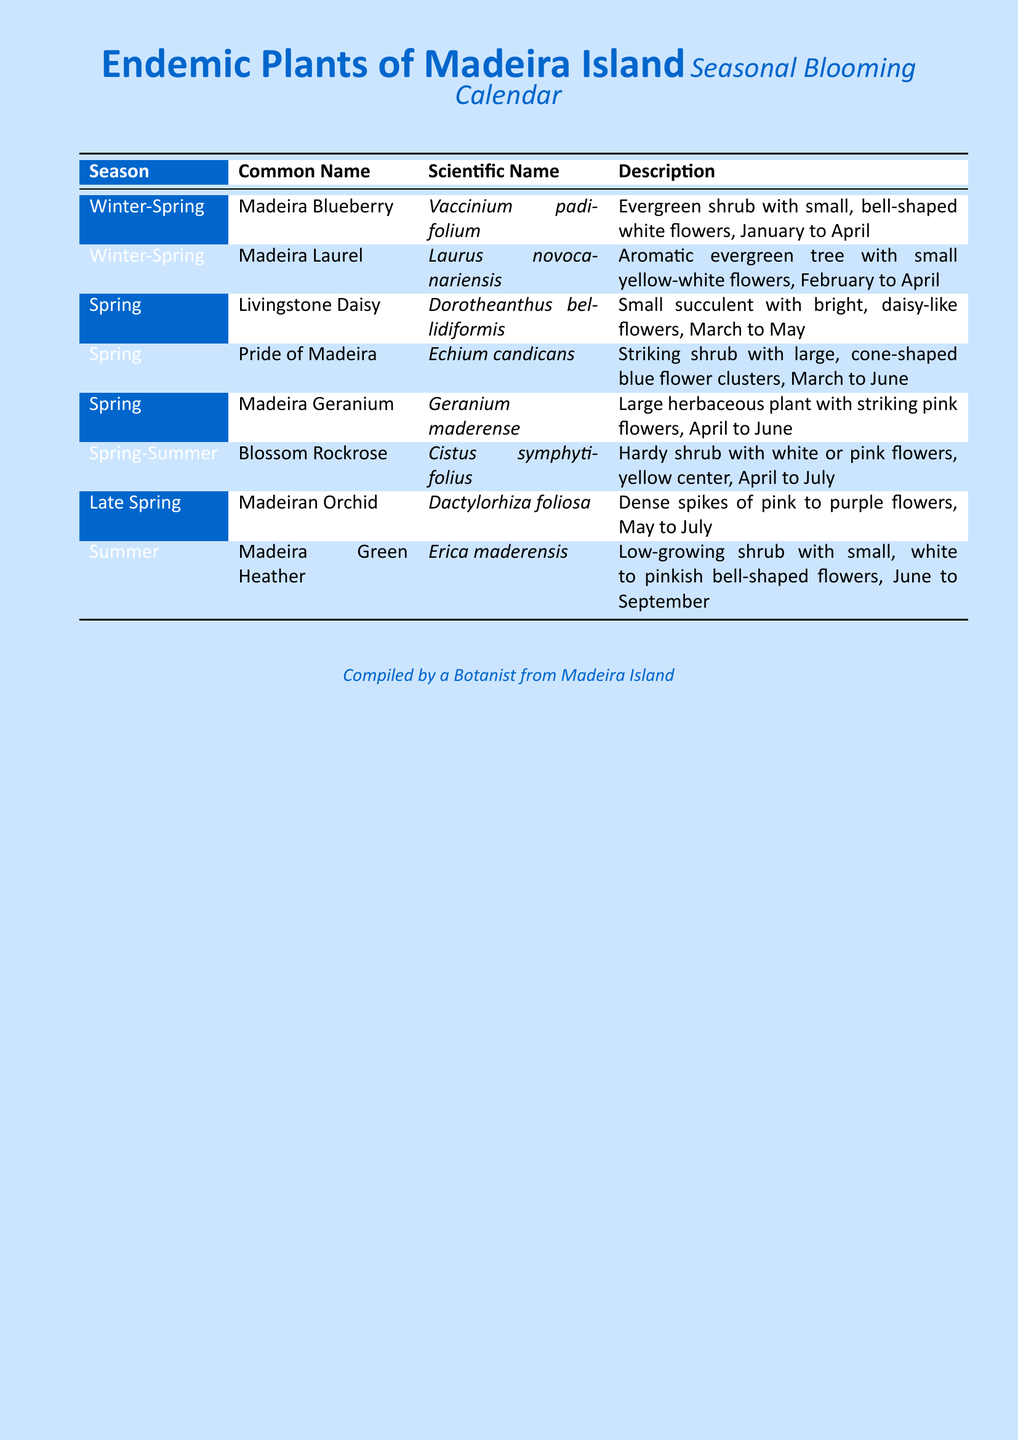What is the common name of \textit{Laurus novocanariensis}? The common name of \textit{Laurus novocanariensis} is described in the document under the Winter-Spring season.
Answer: Madeira Laurel In which season does \textit{Vaccinium padifolium} bloom? The blooming period of \textit{Vaccinium padifolium} is specified for the Winter-Spring season.
Answer: Winter-Spring What are the colors of flowers for \textit{Cistus symphytifolius}? The description of \textit{Cistus symphytifolius} includes white or pink flowers with a yellow center.
Answer: White or pink Which plant has a blooming period from March to May? The document specifies the blooming period of \textit{Dorotheanthus bellidiformis} as March to May.
Answer: Livingstone Daisy How many plants bloom in the Spring season? The document lists all plants under their respective seasons, identifying those that bloom in Spring.
Answer: Three What is the longest blooming period mentioned? The longest blooming period can be identified from examining each plant's flowering duration in the table.
Answer: April to September Which plant is described as having "dense spikes of pink to purple flowers"? This description pertains to the \textit{Dactylorhiza foliosa} listed in the Late Spring section.
Answer: Madeiran Orchid What type of document is this? The main title indicates the type of document it is focused on endemic plants and their blooming seasons.
Answer: Calendar 